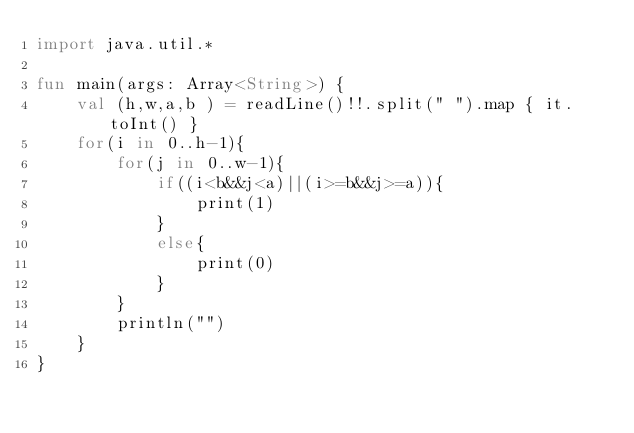Convert code to text. <code><loc_0><loc_0><loc_500><loc_500><_Kotlin_>import java.util.*

fun main(args: Array<String>) {
    val (h,w,a,b ) = readLine()!!.split(" ").map { it.toInt() }
    for(i in 0..h-1){
        for(j in 0..w-1){
            if((i<b&&j<a)||(i>=b&&j>=a)){
                print(1)
            }
            else{
                print(0)
            }
        }
        println("")
    }
}

</code> 